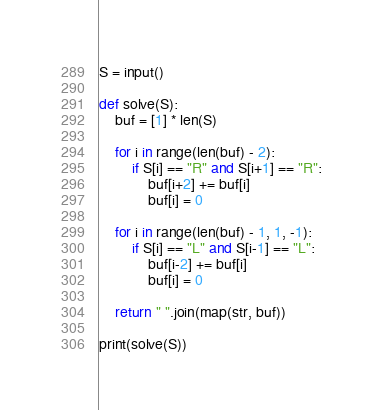Convert code to text. <code><loc_0><loc_0><loc_500><loc_500><_Python_>S = input()
 
def solve(S):
    buf = [1] * len(S)
 
    for i in range(len(buf) - 2):
        if S[i] == "R" and S[i+1] == "R":
            buf[i+2] += buf[i]
            buf[i] = 0
 
    for i in range(len(buf) - 1, 1, -1):
        if S[i] == "L" and S[i-1] == "L":
            buf[i-2] += buf[i]
            buf[i] = 0
 
    return " ".join(map(str, buf))
 
print(solve(S))</code> 